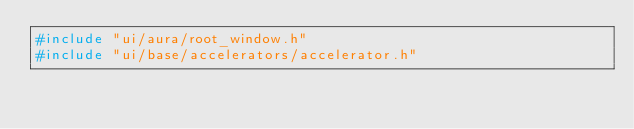<code> <loc_0><loc_0><loc_500><loc_500><_C++_>#include "ui/aura/root_window.h"
#include "ui/base/accelerators/accelerator.h"</code> 